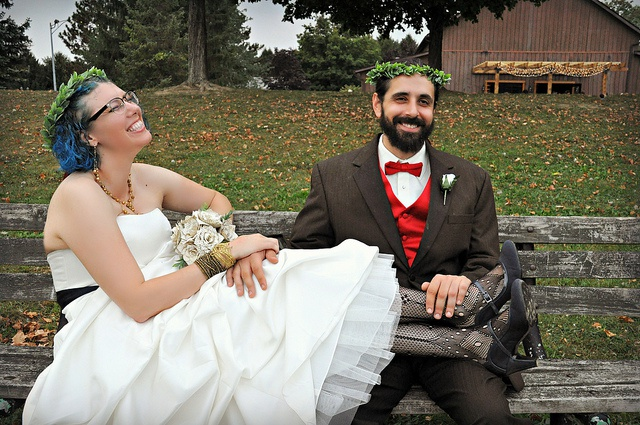Describe the objects in this image and their specific colors. I can see people in black, lightgray, tan, and darkgray tones, people in black and gray tones, bench in black, gray, darkgreen, and darkgray tones, and tie in black, brown, and maroon tones in this image. 